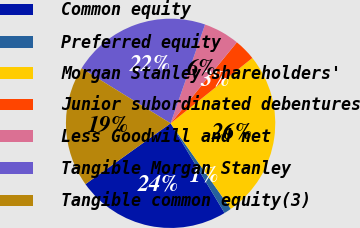Convert chart. <chart><loc_0><loc_0><loc_500><loc_500><pie_chart><fcel>Common equity<fcel>Preferred equity<fcel>Morgan Stanley shareholders'<fcel>Junior subordinated debentures<fcel>Less Goodwill and net<fcel>Tangible Morgan Stanley<fcel>Tangible common equity(3)<nl><fcel>23.75%<fcel>1.14%<fcel>25.97%<fcel>3.36%<fcel>5.57%<fcel>21.53%<fcel>18.68%<nl></chart> 